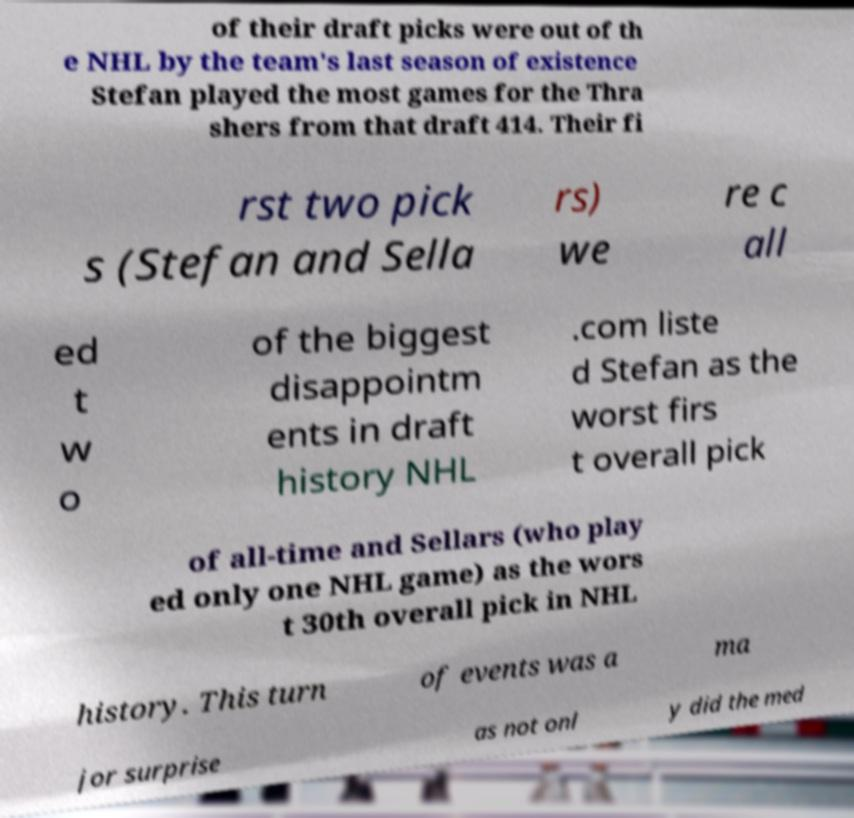For documentation purposes, I need the text within this image transcribed. Could you provide that? of their draft picks were out of th e NHL by the team's last season of existence Stefan played the most games for the Thra shers from that draft 414. Their fi rst two pick s (Stefan and Sella rs) we re c all ed t w o of the biggest disappointm ents in draft history NHL .com liste d Stefan as the worst firs t overall pick of all-time and Sellars (who play ed only one NHL game) as the wors t 30th overall pick in NHL history. This turn of events was a ma jor surprise as not onl y did the med 